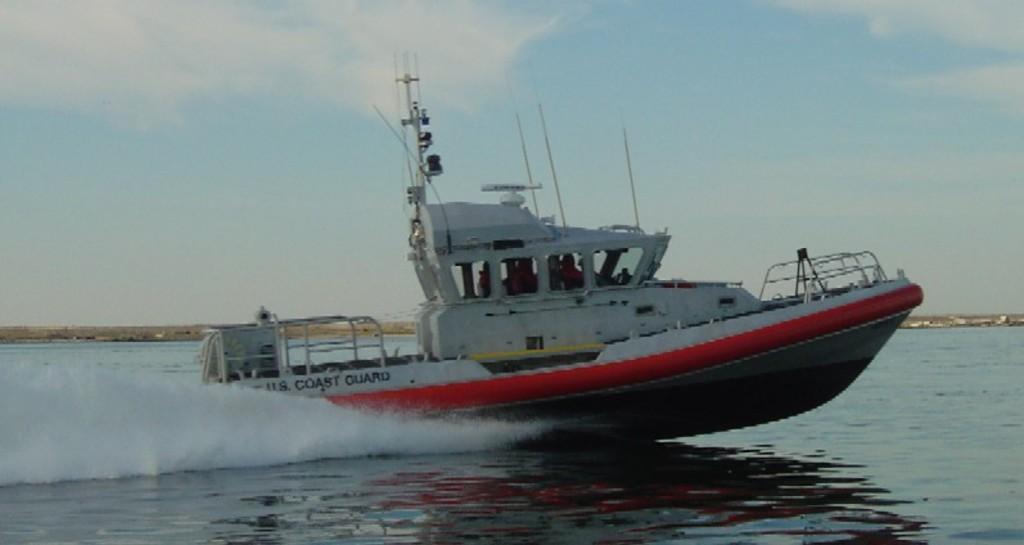In one or two sentences, can you explain what this image depicts? In this picture I can observe a ship sailing in an ocean. In the background I can observe sky. 